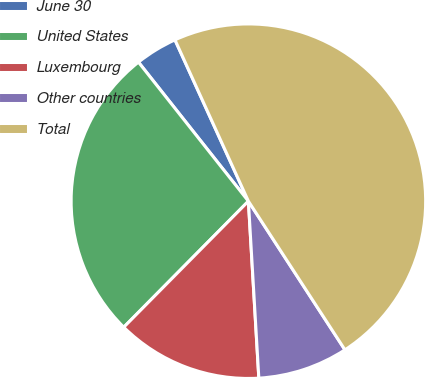Convert chart. <chart><loc_0><loc_0><loc_500><loc_500><pie_chart><fcel>June 30<fcel>United States<fcel>Luxembourg<fcel>Other countries<fcel>Total<nl><fcel>3.85%<fcel>26.94%<fcel>13.35%<fcel>8.23%<fcel>47.63%<nl></chart> 